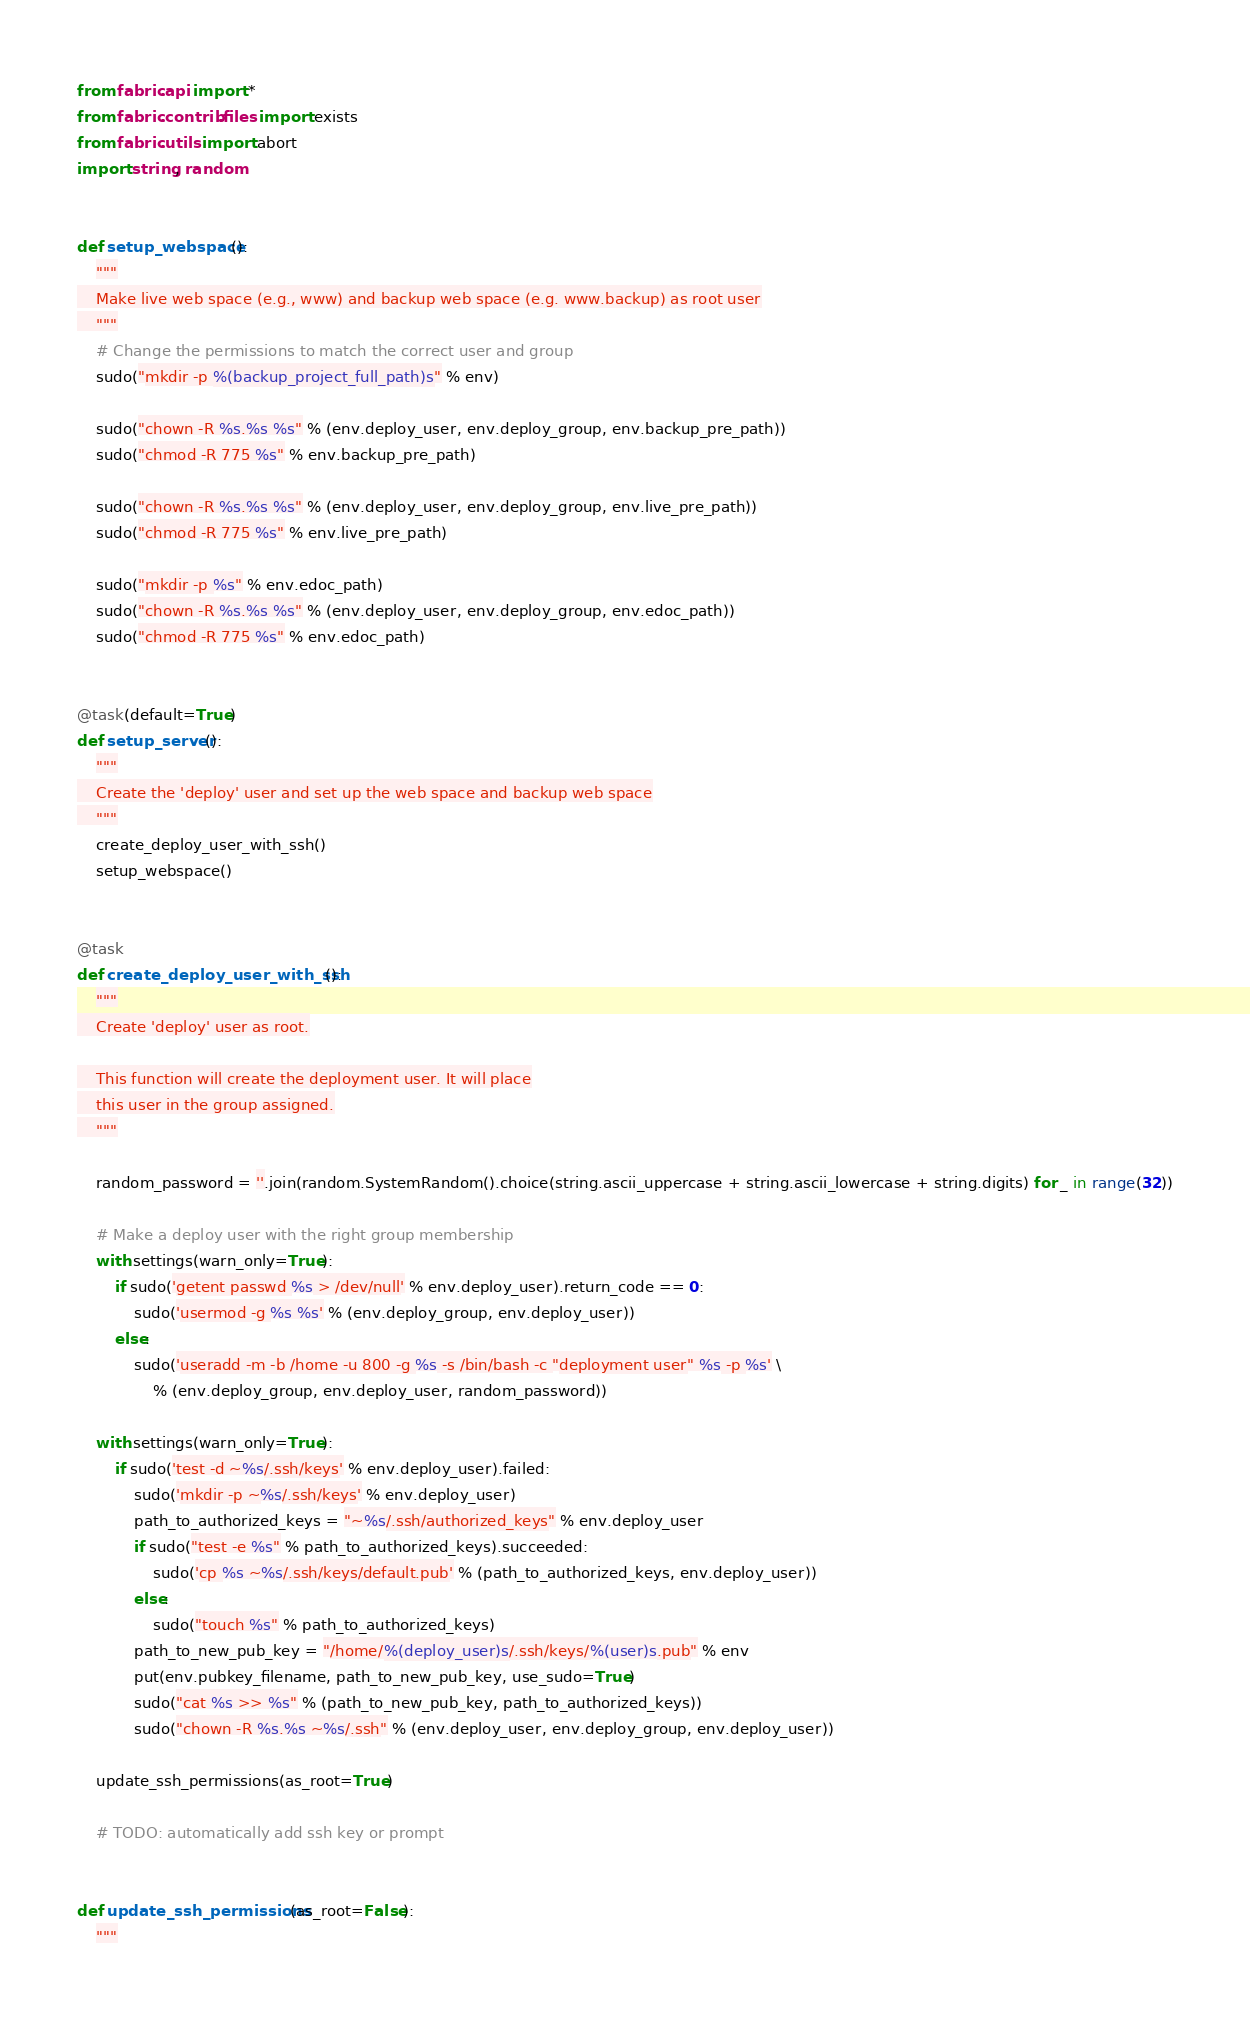Convert code to text. <code><loc_0><loc_0><loc_500><loc_500><_Python_>from fabric.api import *
from fabric.contrib.files import exists
from fabric.utils import abort
import string, random


def setup_webspace():
    """
    Make live web space (e.g., www) and backup web space (e.g. www.backup) as root user
    """
    # Change the permissions to match the correct user and group
    sudo("mkdir -p %(backup_project_full_path)s" % env)

    sudo("chown -R %s.%s %s" % (env.deploy_user, env.deploy_group, env.backup_pre_path))
    sudo("chmod -R 775 %s" % env.backup_pre_path)

    sudo("chown -R %s.%s %s" % (env.deploy_user, env.deploy_group, env.live_pre_path))
    sudo("chmod -R 775 %s" % env.live_pre_path)

    sudo("mkdir -p %s" % env.edoc_path)
    sudo("chown -R %s.%s %s" % (env.deploy_user, env.deploy_group, env.edoc_path))
    sudo("chmod -R 775 %s" % env.edoc_path)


@task(default=True)
def setup_server():
    """
    Create the 'deploy' user and set up the web space and backup web space
    """
    create_deploy_user_with_ssh()
    setup_webspace()


@task
def create_deploy_user_with_ssh():
    """
    Create 'deploy' user as root.

    This function will create the deployment user. It will place
    this user in the group assigned.
    """

    random_password = ''.join(random.SystemRandom().choice(string.ascii_uppercase + string.ascii_lowercase + string.digits) for _ in range(32))

    # Make a deploy user with the right group membership
    with settings(warn_only=True):
        if sudo('getent passwd %s > /dev/null' % env.deploy_user).return_code == 0:
            sudo('usermod -g %s %s' % (env.deploy_group, env.deploy_user))
        else:
            sudo('useradd -m -b /home -u 800 -g %s -s /bin/bash -c "deployment user" %s -p %s' \
                % (env.deploy_group, env.deploy_user, random_password))

    with settings(warn_only=True):
        if sudo('test -d ~%s/.ssh/keys' % env.deploy_user).failed:
            sudo('mkdir -p ~%s/.ssh/keys' % env.deploy_user)
            path_to_authorized_keys = "~%s/.ssh/authorized_keys" % env.deploy_user
            if sudo("test -e %s" % path_to_authorized_keys).succeeded:
                sudo('cp %s ~%s/.ssh/keys/default.pub' % (path_to_authorized_keys, env.deploy_user))
            else:
                sudo("touch %s" % path_to_authorized_keys)
            path_to_new_pub_key = "/home/%(deploy_user)s/.ssh/keys/%(user)s.pub" % env
            put(env.pubkey_filename, path_to_new_pub_key, use_sudo=True)
            sudo("cat %s >> %s" % (path_to_new_pub_key, path_to_authorized_keys))
            sudo("chown -R %s.%s ~%s/.ssh" % (env.deploy_user, env.deploy_group, env.deploy_user))

    update_ssh_permissions(as_root=True)

    # TODO: automatically add ssh key or prompt


def update_ssh_permissions(as_root=False):
    """</code> 